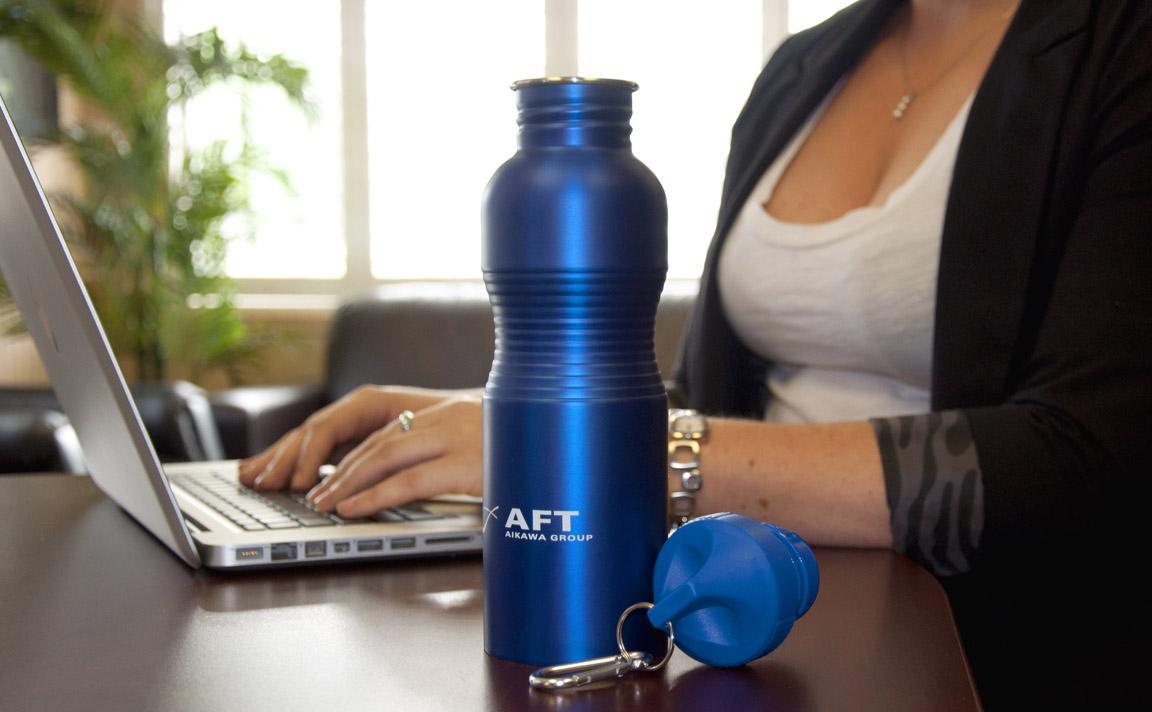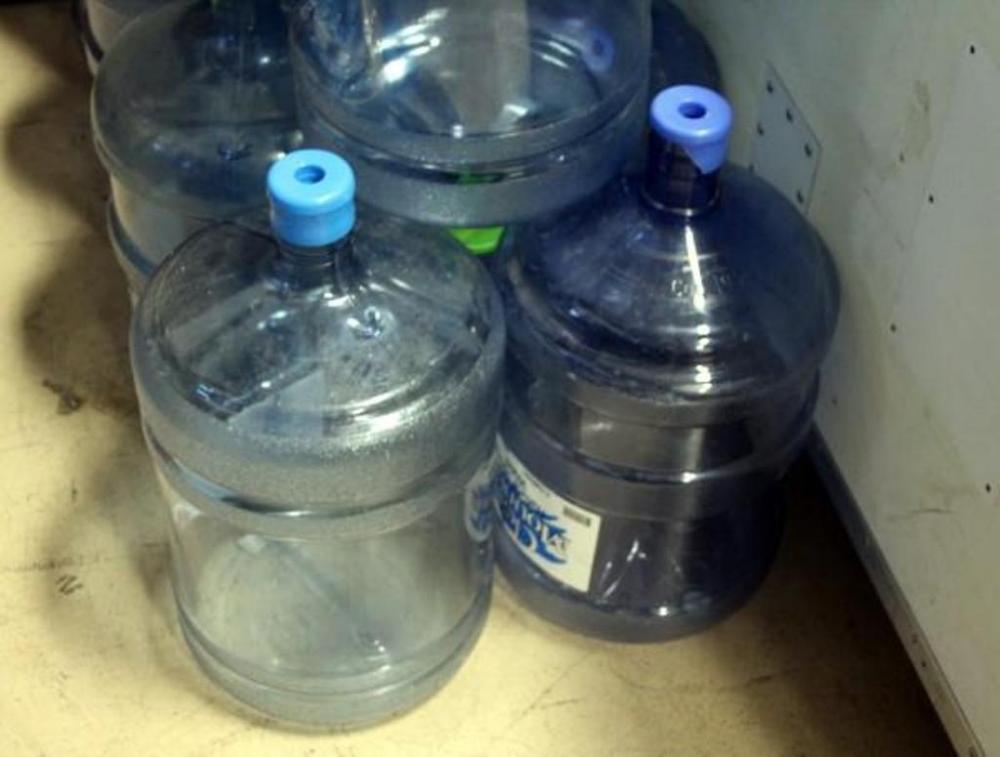The first image is the image on the left, the second image is the image on the right. Considering the images on both sides, is "There are more than three water containers standing up." valid? Answer yes or no. Yes. 